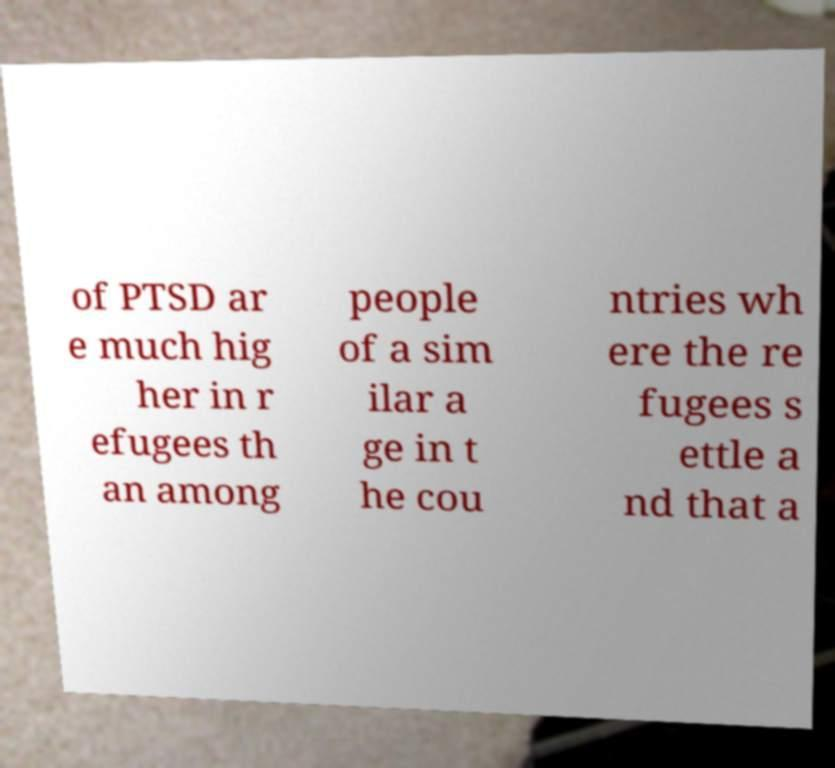Can you read and provide the text displayed in the image?This photo seems to have some interesting text. Can you extract and type it out for me? of PTSD ar e much hig her in r efugees th an among people of a sim ilar a ge in t he cou ntries wh ere the re fugees s ettle a nd that a 